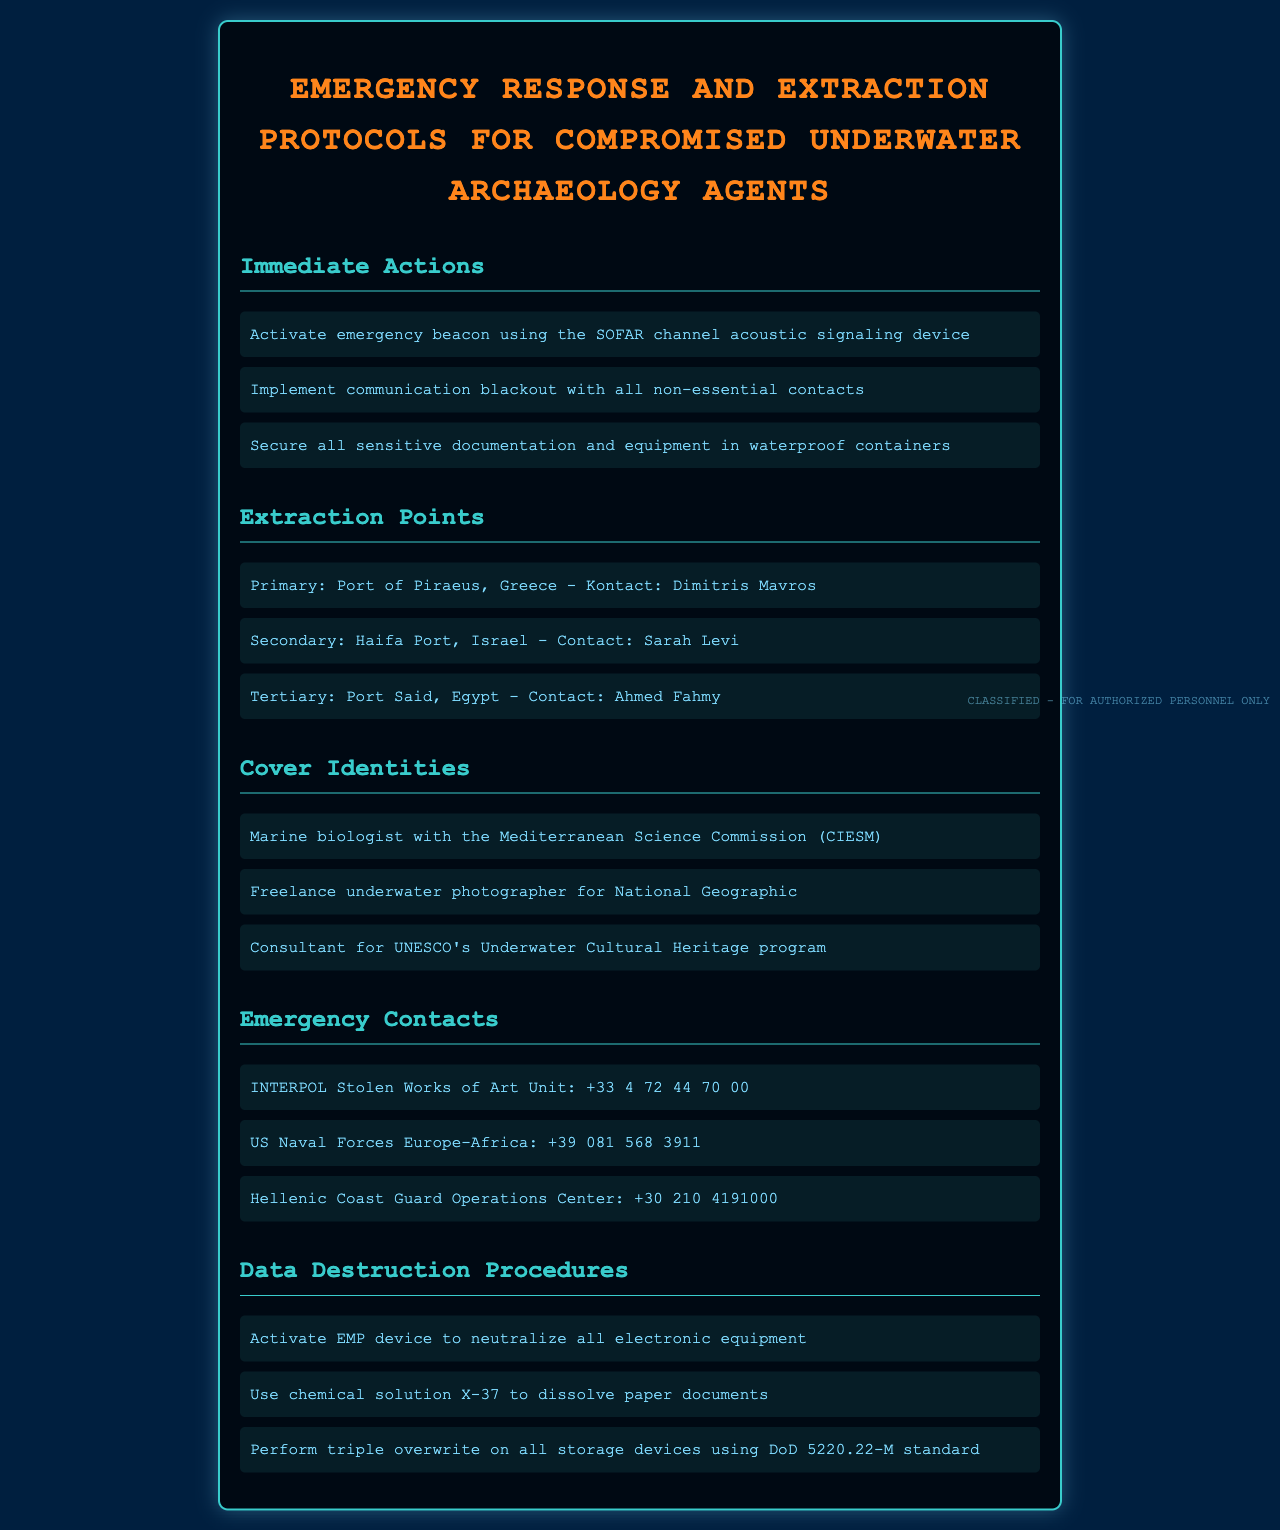what device should be activated in an emergency? The document states that an emergency beacon should be activated using the SOFAR channel acoustic signaling device.
Answer: SOFAR channel acoustic signaling device what is the primary extraction point? The primary extraction point listed in the document is the Port of Piraeus, Greece.
Answer: Port of Piraeus, Greece who is the contact at the secondary extraction point? The contact at the secondary extraction point, Haifa Port, Israel, is Sarah Levi.
Answer: Sarah Levi how many cover identities are provided in the document? The document lists three cover identities for agents.
Answer: Three what should be used to dissolve paper documents? According to the document, chemical solution X-37 should be used to dissolve paper documents.
Answer: chemical solution X-37 which unit can be contacted for stolen works of art? The document indicates that the INTERPOL Stolen Works of Art Unit can be contacted for stolen works of art.
Answer: INTERPOL Stolen Works of Art Unit what is the emergency contact number for the US Naval Forces Europe-Africa? The contact number for the US Naval Forces Europe-Africa listed in the document is +39 081 568 3911.
Answer: +39 081 568 3911 what is the data destruction procedure for electronic equipment? The document states to activate an EMP device to neutralize all electronic equipment.
Answer: activate EMP device 